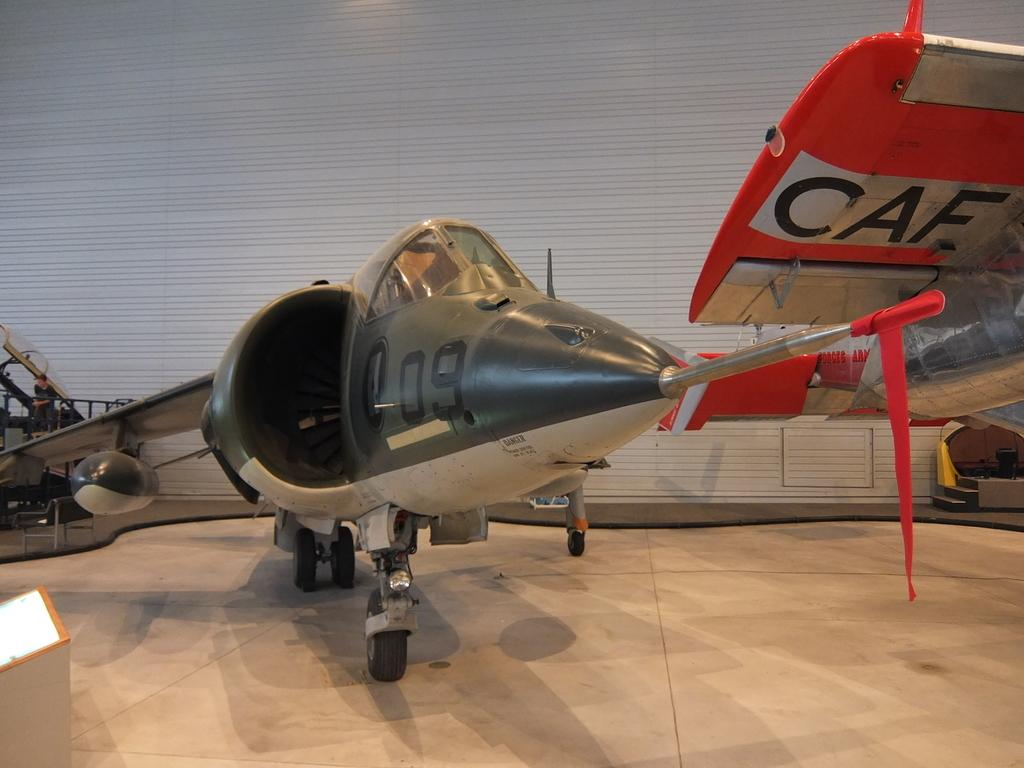<image>
Give a short and clear explanation of the subsequent image. Plane number 09 sits next to a plane with CAF on the wing. 